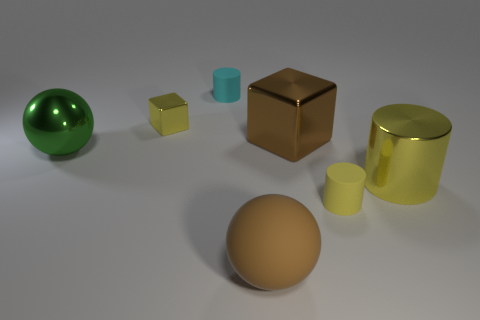Subtract all cubes. How many objects are left? 5 Add 1 big metallic cylinders. How many objects exist? 8 Add 4 rubber things. How many rubber things are left? 7 Add 4 big cyan matte cubes. How many big cyan matte cubes exist? 4 Subtract 0 yellow balls. How many objects are left? 7 Subtract all large yellow metal objects. Subtract all green spheres. How many objects are left? 5 